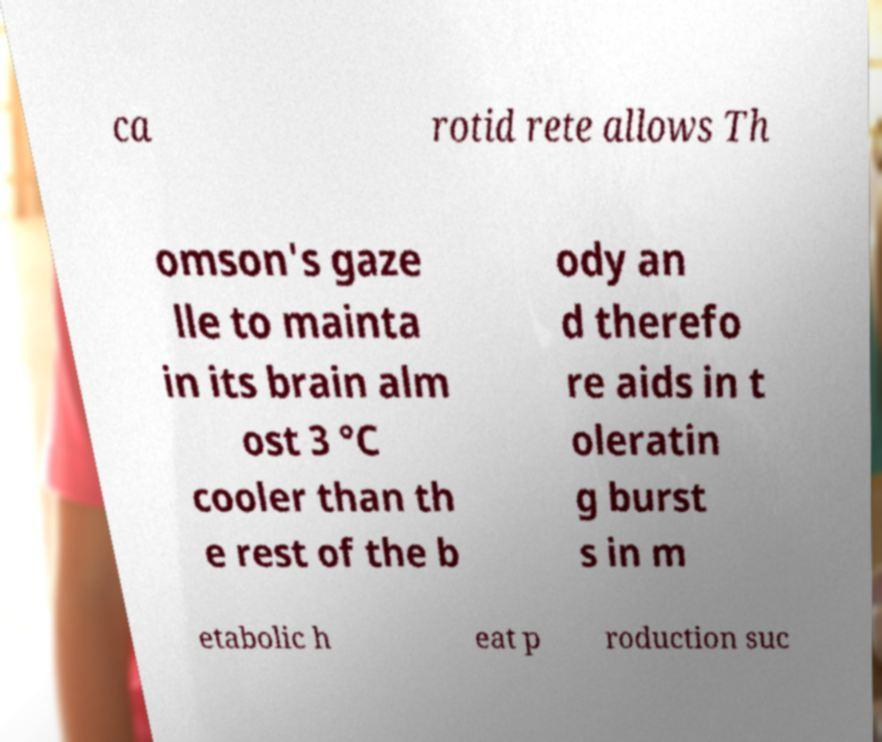Could you extract and type out the text from this image? ca rotid rete allows Th omson's gaze lle to mainta in its brain alm ost 3 °C cooler than th e rest of the b ody an d therefo re aids in t oleratin g burst s in m etabolic h eat p roduction suc 